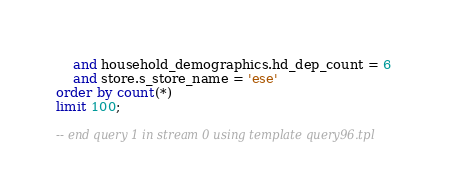Convert code to text. <code><loc_0><loc_0><loc_500><loc_500><_SQL_>    and household_demographics.hd_dep_count = 6
    and store.s_store_name = 'ese'
order by count(*)
limit 100;

-- end query 1 in stream 0 using template query96.tpl
</code> 